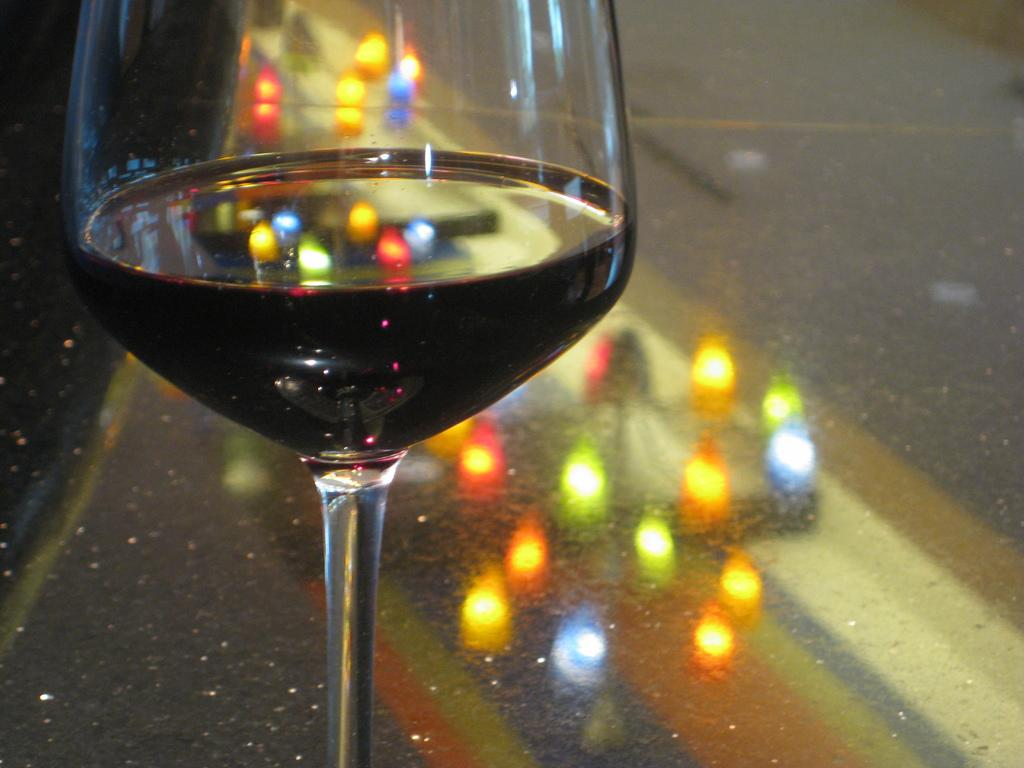What object is present in the image that can hold a liquid? There is a glass in the image. What can be seen on the surface of the glass? The reflection of lights is visible on the glass. How many legs can be seen on the fowl in the image? There is no fowl present in the image, so it is not possible to determine the number of legs. 